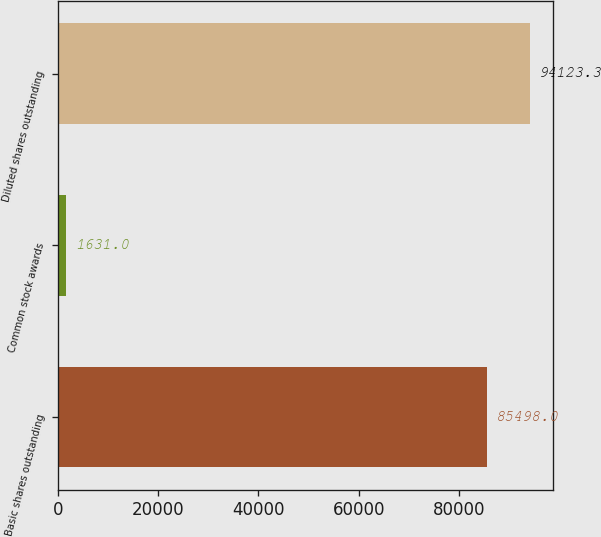<chart> <loc_0><loc_0><loc_500><loc_500><bar_chart><fcel>Basic shares outstanding<fcel>Common stock awards<fcel>Diluted shares outstanding<nl><fcel>85498<fcel>1631<fcel>94123.3<nl></chart> 